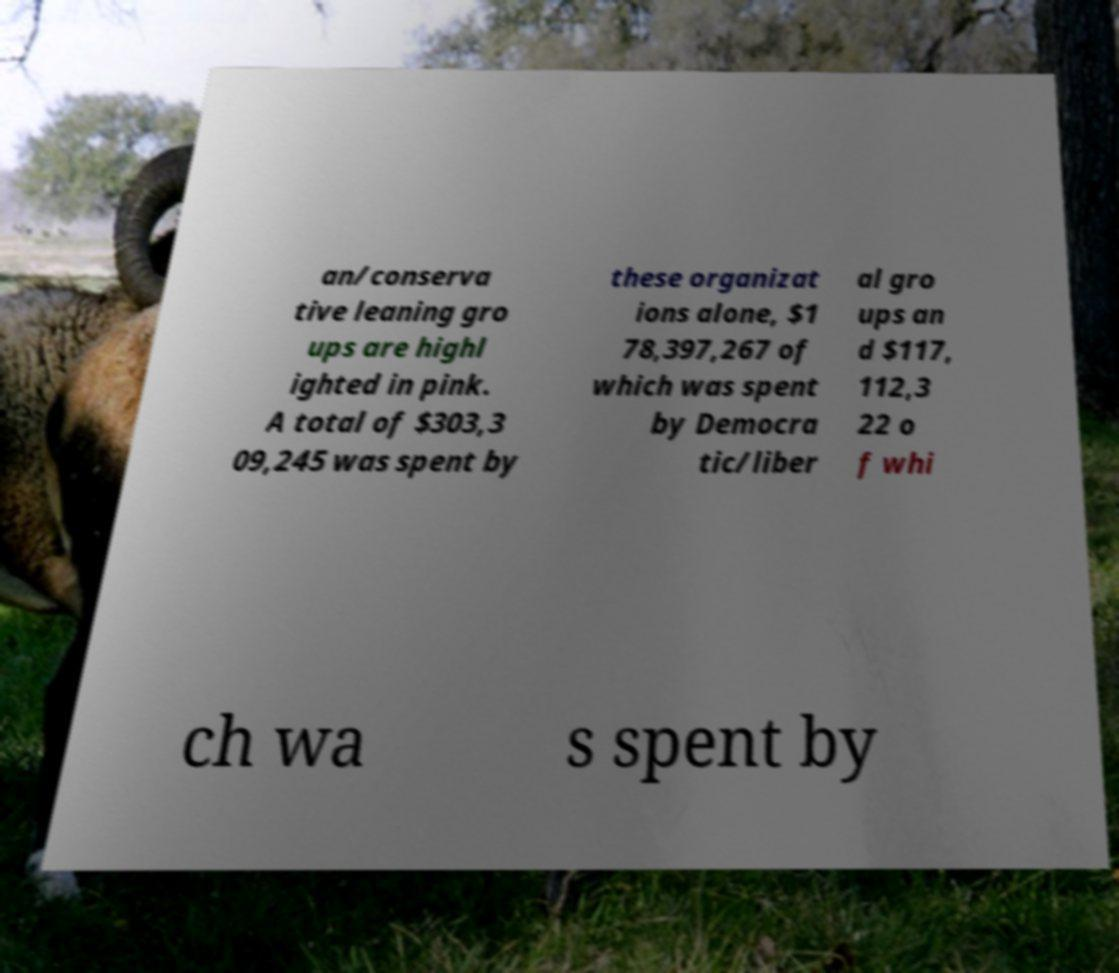There's text embedded in this image that I need extracted. Can you transcribe it verbatim? an/conserva tive leaning gro ups are highl ighted in pink. A total of $303,3 09,245 was spent by these organizat ions alone, $1 78,397,267 of which was spent by Democra tic/liber al gro ups an d $117, 112,3 22 o f whi ch wa s spent by 